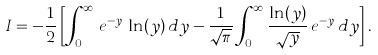Convert formula to latex. <formula><loc_0><loc_0><loc_500><loc_500>I = - \frac { 1 } { 2 } \left [ \int _ { 0 } ^ { \infty } \, e ^ { - y } \, \ln ( y ) \, d y - \frac { 1 } { \sqrt { \pi } } \int _ { 0 } ^ { \infty } \frac { \ln ( y ) } { \sqrt { y } } \, e ^ { - y } \, d y \right ] .</formula> 